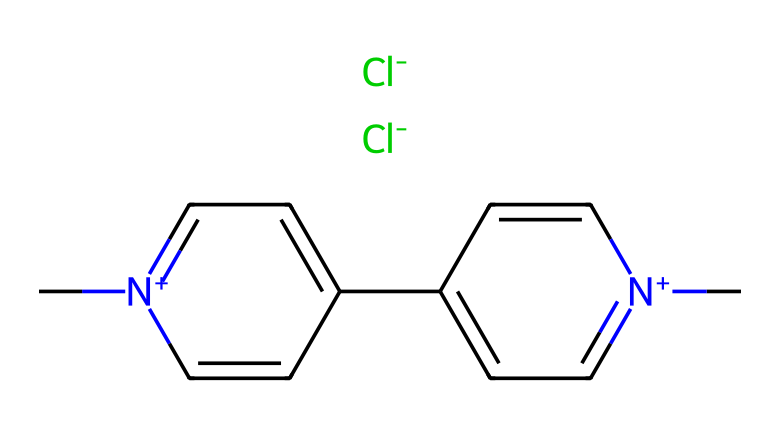What is the name of this chemical? The provided SMILES representation corresponds to the herbicide Paraquat. The structure includes two positively charged nitrogen atoms and two chloride ions, consistent with Paraquat's known chemical name.
Answer: Paraquat How many nitrogen atoms are present in this chemical? Analyzing the SMILES, there are two nitrogen atoms indicated by the notation [n+] in the structure. Each of these refers to a nitrogen that is positively charged, and both are integral parts of the aromatic structure.
Answer: 2 What type of herbicide is Paraquat classified as? Paraquat is known as a bipyridylium herbicide due to its bipyridyl structure, which consists of two pyridine-like rings fused together, contributing to its herbicidal properties.
Answer: Bipyridylium What is the charge of the nitrogen atoms in Paraquat? The representation shows the nitrogen atoms indicated as [n+], which means they each carry a positive charge. This is an important characteristic affecting the herbicide's interaction with plant systems.
Answer: Positive How does the presence of chlorine ions affect the herbicidal properties of Paraquat? Chlorine atoms are halide substituents contributing to the herbicide's effectiveness and stability. In herbicides, halogens can enhance bioactivity and persistence in the environment.
Answer: Enhances activity 